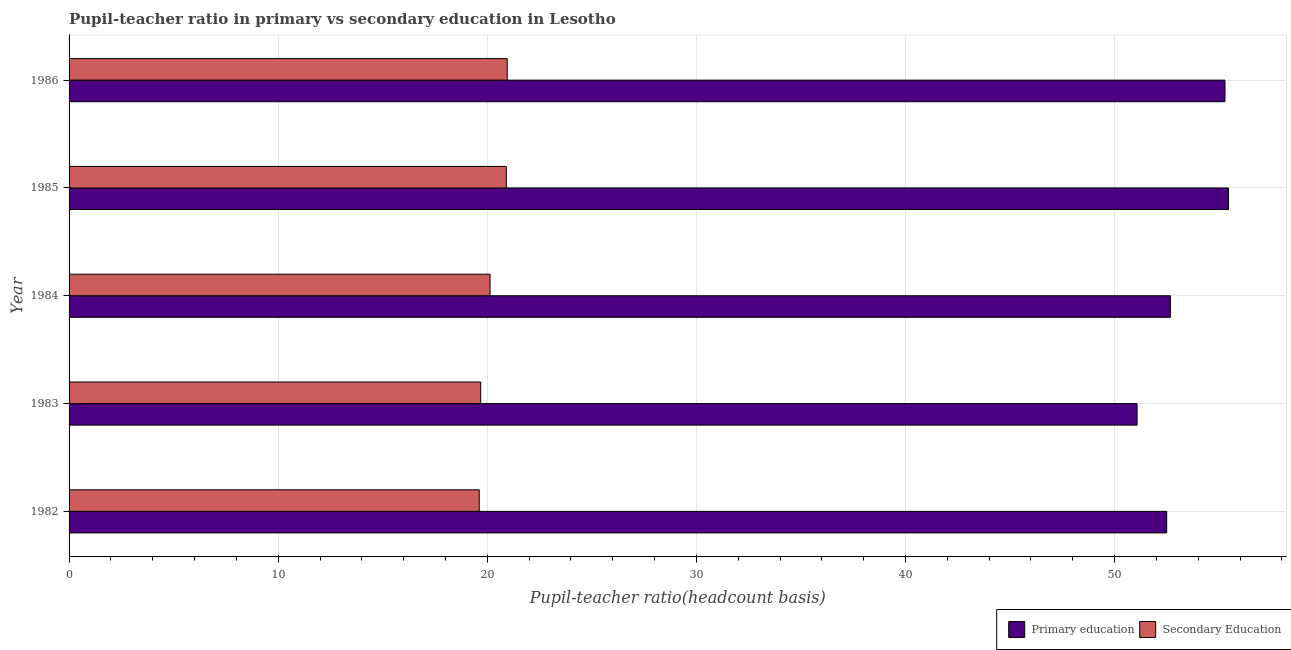How many groups of bars are there?
Your response must be concise. 5. Are the number of bars on each tick of the Y-axis equal?
Offer a terse response. Yes. How many bars are there on the 1st tick from the top?
Your answer should be compact. 2. How many bars are there on the 5th tick from the bottom?
Your response must be concise. 2. In how many cases, is the number of bars for a given year not equal to the number of legend labels?
Ensure brevity in your answer.  0. What is the pupil teacher ratio on secondary education in 1986?
Your answer should be compact. 20.95. Across all years, what is the maximum pupil-teacher ratio in primary education?
Make the answer very short. 55.45. Across all years, what is the minimum pupil-teacher ratio in primary education?
Keep it short and to the point. 51.07. In which year was the pupil teacher ratio on secondary education minimum?
Provide a short and direct response. 1982. What is the total pupil teacher ratio on secondary education in the graph?
Provide a short and direct response. 101.3. What is the difference between the pupil-teacher ratio in primary education in 1982 and that in 1984?
Offer a terse response. -0.18. What is the difference between the pupil-teacher ratio in primary education in 1984 and the pupil teacher ratio on secondary education in 1985?
Offer a terse response. 31.76. What is the average pupil teacher ratio on secondary education per year?
Ensure brevity in your answer.  20.26. In the year 1986, what is the difference between the pupil teacher ratio on secondary education and pupil-teacher ratio in primary education?
Ensure brevity in your answer.  -34.33. What is the ratio of the pupil teacher ratio on secondary education in 1984 to that in 1986?
Your answer should be compact. 0.96. What is the difference between the highest and the second highest pupil teacher ratio on secondary education?
Provide a succinct answer. 0.04. What is the difference between the highest and the lowest pupil teacher ratio on secondary education?
Your response must be concise. 1.34. Is the sum of the pupil-teacher ratio in primary education in 1982 and 1984 greater than the maximum pupil teacher ratio on secondary education across all years?
Provide a short and direct response. Yes. What does the 1st bar from the top in 1982 represents?
Make the answer very short. Secondary Education. What does the 2nd bar from the bottom in 1985 represents?
Your answer should be very brief. Secondary Education. Are all the bars in the graph horizontal?
Offer a very short reply. Yes. What is the difference between two consecutive major ticks on the X-axis?
Provide a succinct answer. 10. Does the graph contain any zero values?
Provide a succinct answer. No. Does the graph contain grids?
Offer a terse response. Yes. How many legend labels are there?
Your answer should be compact. 2. What is the title of the graph?
Give a very brief answer. Pupil-teacher ratio in primary vs secondary education in Lesotho. Does "International Visitors" appear as one of the legend labels in the graph?
Offer a terse response. No. What is the label or title of the X-axis?
Give a very brief answer. Pupil-teacher ratio(headcount basis). What is the label or title of the Y-axis?
Your response must be concise. Year. What is the Pupil-teacher ratio(headcount basis) of Primary education in 1982?
Offer a terse response. 52.49. What is the Pupil-teacher ratio(headcount basis) in Secondary Education in 1982?
Your answer should be compact. 19.61. What is the Pupil-teacher ratio(headcount basis) in Primary education in 1983?
Your response must be concise. 51.07. What is the Pupil-teacher ratio(headcount basis) in Secondary Education in 1983?
Ensure brevity in your answer.  19.69. What is the Pupil-teacher ratio(headcount basis) in Primary education in 1984?
Your answer should be very brief. 52.67. What is the Pupil-teacher ratio(headcount basis) of Secondary Education in 1984?
Your response must be concise. 20.13. What is the Pupil-teacher ratio(headcount basis) in Primary education in 1985?
Make the answer very short. 55.45. What is the Pupil-teacher ratio(headcount basis) of Secondary Education in 1985?
Your answer should be very brief. 20.91. What is the Pupil-teacher ratio(headcount basis) of Primary education in 1986?
Make the answer very short. 55.28. What is the Pupil-teacher ratio(headcount basis) of Secondary Education in 1986?
Your answer should be compact. 20.95. Across all years, what is the maximum Pupil-teacher ratio(headcount basis) of Primary education?
Provide a short and direct response. 55.45. Across all years, what is the maximum Pupil-teacher ratio(headcount basis) in Secondary Education?
Your answer should be very brief. 20.95. Across all years, what is the minimum Pupil-teacher ratio(headcount basis) in Primary education?
Your response must be concise. 51.07. Across all years, what is the minimum Pupil-teacher ratio(headcount basis) in Secondary Education?
Make the answer very short. 19.61. What is the total Pupil-teacher ratio(headcount basis) of Primary education in the graph?
Make the answer very short. 266.96. What is the total Pupil-teacher ratio(headcount basis) of Secondary Education in the graph?
Offer a very short reply. 101.3. What is the difference between the Pupil-teacher ratio(headcount basis) of Primary education in 1982 and that in 1983?
Your response must be concise. 1.42. What is the difference between the Pupil-teacher ratio(headcount basis) in Secondary Education in 1982 and that in 1983?
Provide a succinct answer. -0.07. What is the difference between the Pupil-teacher ratio(headcount basis) of Primary education in 1982 and that in 1984?
Provide a succinct answer. -0.18. What is the difference between the Pupil-teacher ratio(headcount basis) of Secondary Education in 1982 and that in 1984?
Provide a succinct answer. -0.52. What is the difference between the Pupil-teacher ratio(headcount basis) of Primary education in 1982 and that in 1985?
Offer a terse response. -2.96. What is the difference between the Pupil-teacher ratio(headcount basis) in Secondary Education in 1982 and that in 1985?
Provide a short and direct response. -1.3. What is the difference between the Pupil-teacher ratio(headcount basis) in Primary education in 1982 and that in 1986?
Offer a terse response. -2.79. What is the difference between the Pupil-teacher ratio(headcount basis) in Secondary Education in 1982 and that in 1986?
Give a very brief answer. -1.34. What is the difference between the Pupil-teacher ratio(headcount basis) in Primary education in 1983 and that in 1984?
Provide a short and direct response. -1.6. What is the difference between the Pupil-teacher ratio(headcount basis) in Secondary Education in 1983 and that in 1984?
Provide a succinct answer. -0.45. What is the difference between the Pupil-teacher ratio(headcount basis) of Primary education in 1983 and that in 1985?
Your answer should be very brief. -4.37. What is the difference between the Pupil-teacher ratio(headcount basis) of Secondary Education in 1983 and that in 1985?
Offer a very short reply. -1.23. What is the difference between the Pupil-teacher ratio(headcount basis) of Primary education in 1983 and that in 1986?
Make the answer very short. -4.21. What is the difference between the Pupil-teacher ratio(headcount basis) in Secondary Education in 1983 and that in 1986?
Give a very brief answer. -1.27. What is the difference between the Pupil-teacher ratio(headcount basis) in Primary education in 1984 and that in 1985?
Your answer should be very brief. -2.78. What is the difference between the Pupil-teacher ratio(headcount basis) of Secondary Education in 1984 and that in 1985?
Provide a succinct answer. -0.78. What is the difference between the Pupil-teacher ratio(headcount basis) in Primary education in 1984 and that in 1986?
Your answer should be very brief. -2.61. What is the difference between the Pupil-teacher ratio(headcount basis) of Secondary Education in 1984 and that in 1986?
Your answer should be compact. -0.82. What is the difference between the Pupil-teacher ratio(headcount basis) in Primary education in 1985 and that in 1986?
Ensure brevity in your answer.  0.17. What is the difference between the Pupil-teacher ratio(headcount basis) in Secondary Education in 1985 and that in 1986?
Your response must be concise. -0.04. What is the difference between the Pupil-teacher ratio(headcount basis) of Primary education in 1982 and the Pupil-teacher ratio(headcount basis) of Secondary Education in 1983?
Keep it short and to the point. 32.81. What is the difference between the Pupil-teacher ratio(headcount basis) in Primary education in 1982 and the Pupil-teacher ratio(headcount basis) in Secondary Education in 1984?
Make the answer very short. 32.36. What is the difference between the Pupil-teacher ratio(headcount basis) of Primary education in 1982 and the Pupil-teacher ratio(headcount basis) of Secondary Education in 1985?
Provide a succinct answer. 31.58. What is the difference between the Pupil-teacher ratio(headcount basis) in Primary education in 1982 and the Pupil-teacher ratio(headcount basis) in Secondary Education in 1986?
Ensure brevity in your answer.  31.54. What is the difference between the Pupil-teacher ratio(headcount basis) in Primary education in 1983 and the Pupil-teacher ratio(headcount basis) in Secondary Education in 1984?
Provide a succinct answer. 30.94. What is the difference between the Pupil-teacher ratio(headcount basis) of Primary education in 1983 and the Pupil-teacher ratio(headcount basis) of Secondary Education in 1985?
Your answer should be compact. 30.16. What is the difference between the Pupil-teacher ratio(headcount basis) in Primary education in 1983 and the Pupil-teacher ratio(headcount basis) in Secondary Education in 1986?
Your response must be concise. 30.12. What is the difference between the Pupil-teacher ratio(headcount basis) of Primary education in 1984 and the Pupil-teacher ratio(headcount basis) of Secondary Education in 1985?
Make the answer very short. 31.76. What is the difference between the Pupil-teacher ratio(headcount basis) of Primary education in 1984 and the Pupil-teacher ratio(headcount basis) of Secondary Education in 1986?
Keep it short and to the point. 31.72. What is the difference between the Pupil-teacher ratio(headcount basis) of Primary education in 1985 and the Pupil-teacher ratio(headcount basis) of Secondary Education in 1986?
Your response must be concise. 34.49. What is the average Pupil-teacher ratio(headcount basis) of Primary education per year?
Make the answer very short. 53.39. What is the average Pupil-teacher ratio(headcount basis) in Secondary Education per year?
Keep it short and to the point. 20.26. In the year 1982, what is the difference between the Pupil-teacher ratio(headcount basis) of Primary education and Pupil-teacher ratio(headcount basis) of Secondary Education?
Ensure brevity in your answer.  32.88. In the year 1983, what is the difference between the Pupil-teacher ratio(headcount basis) of Primary education and Pupil-teacher ratio(headcount basis) of Secondary Education?
Your answer should be very brief. 31.39. In the year 1984, what is the difference between the Pupil-teacher ratio(headcount basis) of Primary education and Pupil-teacher ratio(headcount basis) of Secondary Education?
Offer a very short reply. 32.54. In the year 1985, what is the difference between the Pupil-teacher ratio(headcount basis) of Primary education and Pupil-teacher ratio(headcount basis) of Secondary Education?
Keep it short and to the point. 34.54. In the year 1986, what is the difference between the Pupil-teacher ratio(headcount basis) in Primary education and Pupil-teacher ratio(headcount basis) in Secondary Education?
Keep it short and to the point. 34.33. What is the ratio of the Pupil-teacher ratio(headcount basis) of Primary education in 1982 to that in 1983?
Provide a succinct answer. 1.03. What is the ratio of the Pupil-teacher ratio(headcount basis) in Secondary Education in 1982 to that in 1984?
Offer a terse response. 0.97. What is the ratio of the Pupil-teacher ratio(headcount basis) of Primary education in 1982 to that in 1985?
Make the answer very short. 0.95. What is the ratio of the Pupil-teacher ratio(headcount basis) in Secondary Education in 1982 to that in 1985?
Give a very brief answer. 0.94. What is the ratio of the Pupil-teacher ratio(headcount basis) in Primary education in 1982 to that in 1986?
Provide a short and direct response. 0.95. What is the ratio of the Pupil-teacher ratio(headcount basis) of Secondary Education in 1982 to that in 1986?
Offer a terse response. 0.94. What is the ratio of the Pupil-teacher ratio(headcount basis) of Primary education in 1983 to that in 1984?
Give a very brief answer. 0.97. What is the ratio of the Pupil-teacher ratio(headcount basis) in Secondary Education in 1983 to that in 1984?
Make the answer very short. 0.98. What is the ratio of the Pupil-teacher ratio(headcount basis) of Primary education in 1983 to that in 1985?
Ensure brevity in your answer.  0.92. What is the ratio of the Pupil-teacher ratio(headcount basis) in Secondary Education in 1983 to that in 1985?
Your answer should be compact. 0.94. What is the ratio of the Pupil-teacher ratio(headcount basis) of Primary education in 1983 to that in 1986?
Your response must be concise. 0.92. What is the ratio of the Pupil-teacher ratio(headcount basis) in Secondary Education in 1983 to that in 1986?
Keep it short and to the point. 0.94. What is the ratio of the Pupil-teacher ratio(headcount basis) in Primary education in 1984 to that in 1985?
Offer a very short reply. 0.95. What is the ratio of the Pupil-teacher ratio(headcount basis) of Secondary Education in 1984 to that in 1985?
Keep it short and to the point. 0.96. What is the ratio of the Pupil-teacher ratio(headcount basis) in Primary education in 1984 to that in 1986?
Offer a very short reply. 0.95. What is the ratio of the Pupil-teacher ratio(headcount basis) of Secondary Education in 1984 to that in 1986?
Offer a very short reply. 0.96. What is the ratio of the Pupil-teacher ratio(headcount basis) of Primary education in 1985 to that in 1986?
Your response must be concise. 1. What is the ratio of the Pupil-teacher ratio(headcount basis) of Secondary Education in 1985 to that in 1986?
Provide a succinct answer. 1. What is the difference between the highest and the second highest Pupil-teacher ratio(headcount basis) of Primary education?
Provide a short and direct response. 0.17. What is the difference between the highest and the second highest Pupil-teacher ratio(headcount basis) of Secondary Education?
Your answer should be compact. 0.04. What is the difference between the highest and the lowest Pupil-teacher ratio(headcount basis) of Primary education?
Offer a very short reply. 4.37. What is the difference between the highest and the lowest Pupil-teacher ratio(headcount basis) in Secondary Education?
Ensure brevity in your answer.  1.34. 